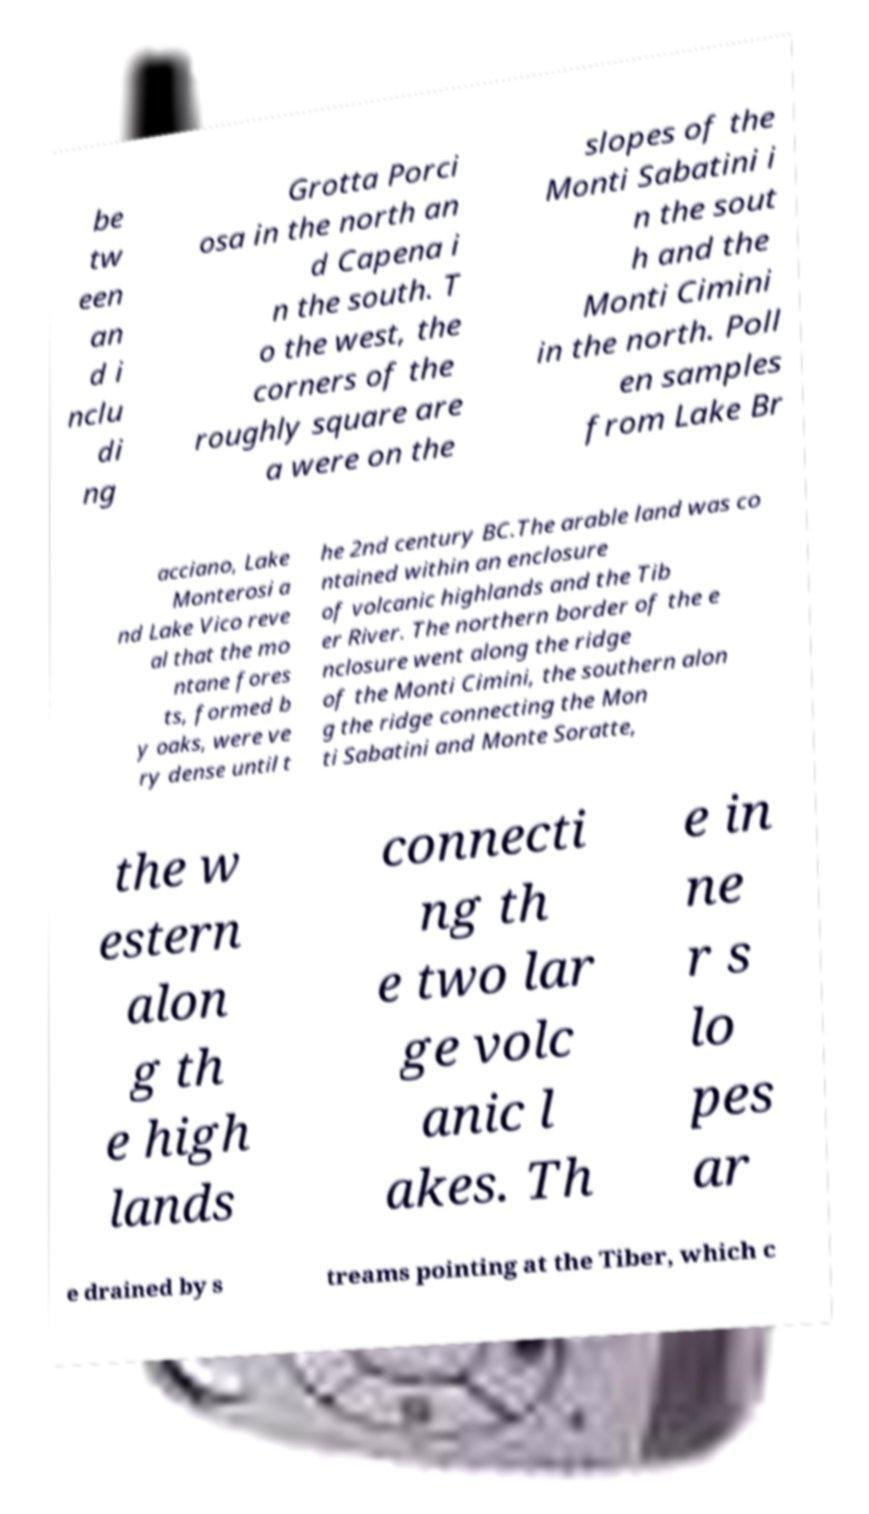Can you accurately transcribe the text from the provided image for me? be tw een an d i nclu di ng Grotta Porci osa in the north an d Capena i n the south. T o the west, the corners of the roughly square are a were on the slopes of the Monti Sabatini i n the sout h and the Monti Cimini in the north. Poll en samples from Lake Br acciano, Lake Monterosi a nd Lake Vico reve al that the mo ntane fores ts, formed b y oaks, were ve ry dense until t he 2nd century BC.The arable land was co ntained within an enclosure of volcanic highlands and the Tib er River. The northern border of the e nclosure went along the ridge of the Monti Cimini, the southern alon g the ridge connecting the Mon ti Sabatini and Monte Soratte, the w estern alon g th e high lands connecti ng th e two lar ge volc anic l akes. Th e in ne r s lo pes ar e drained by s treams pointing at the Tiber, which c 